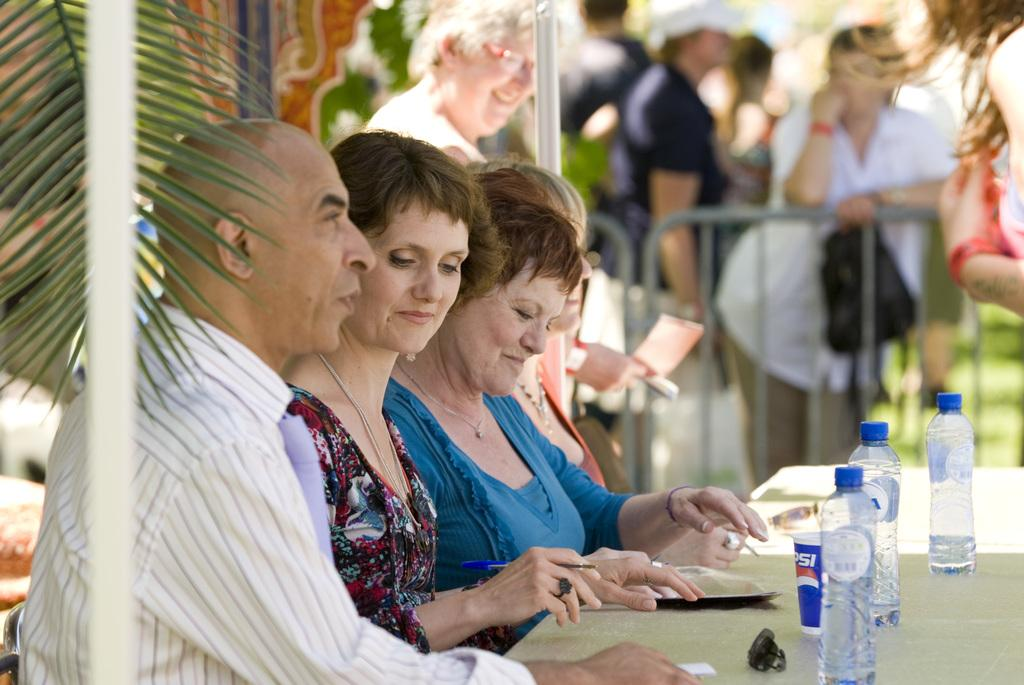How many people are in the image? There are people in the image, but the exact number is not specified. What is the primary object in the image? There is a table in the image. What items can be seen on the table? There are bottles and glasses on the table. What type of vegetation is visible in the image? There is a leaf visible at the top of the image, and there is grass in the image. What can be seen in the background of the image? There are trees in the background of the image. What type of blood is visible on the fan in the image? There is no fan or blood present in the image. 